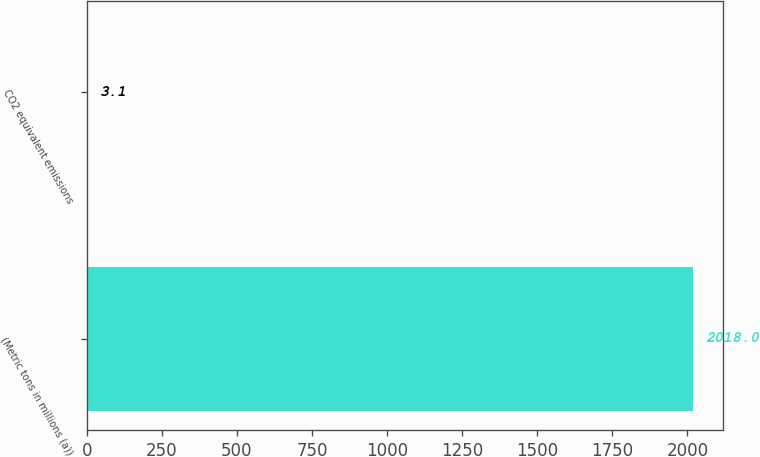<chart> <loc_0><loc_0><loc_500><loc_500><bar_chart><fcel>(Metric tons in millions (a))<fcel>CO2 equivalent emissions<nl><fcel>2018<fcel>3.1<nl></chart> 